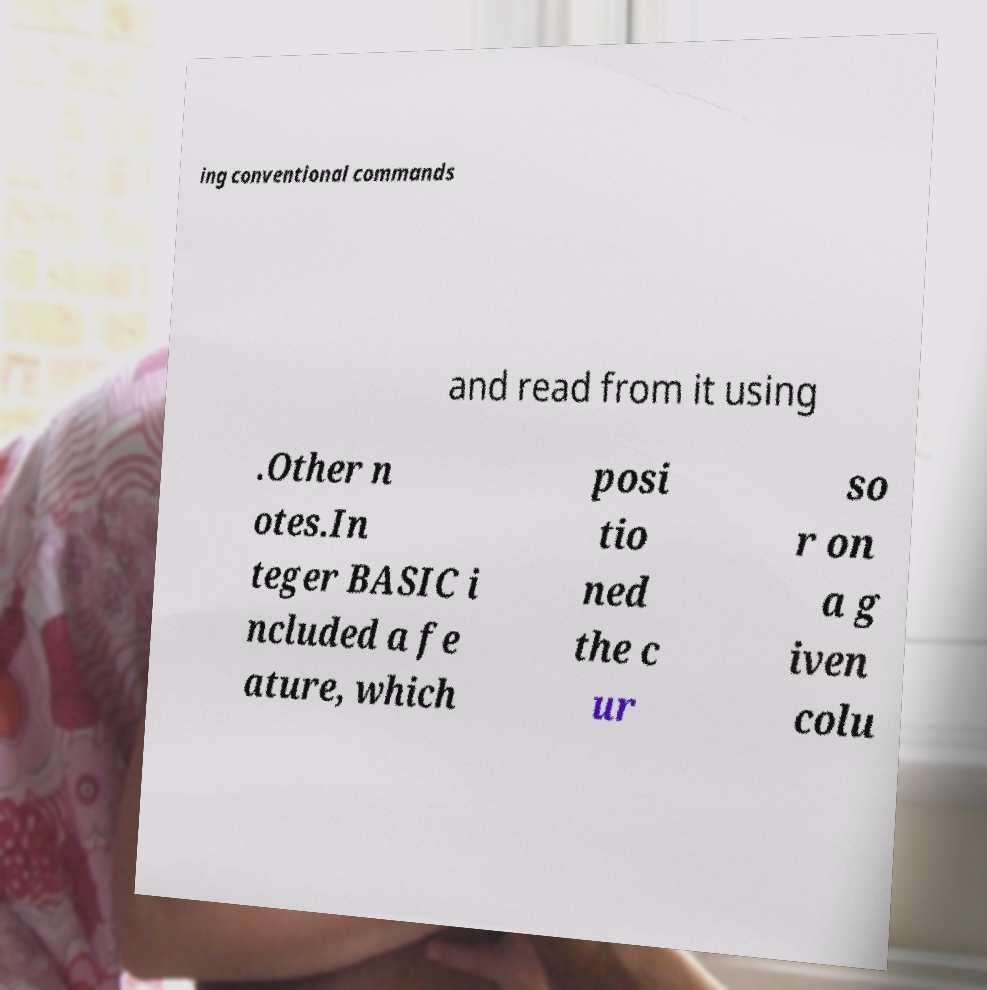Please identify and transcribe the text found in this image. ing conventional commands and read from it using .Other n otes.In teger BASIC i ncluded a fe ature, which posi tio ned the c ur so r on a g iven colu 